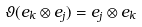Convert formula to latex. <formula><loc_0><loc_0><loc_500><loc_500>\vartheta ( e _ { k } \otimes e _ { j } ) = e _ { j } \otimes e _ { k }</formula> 